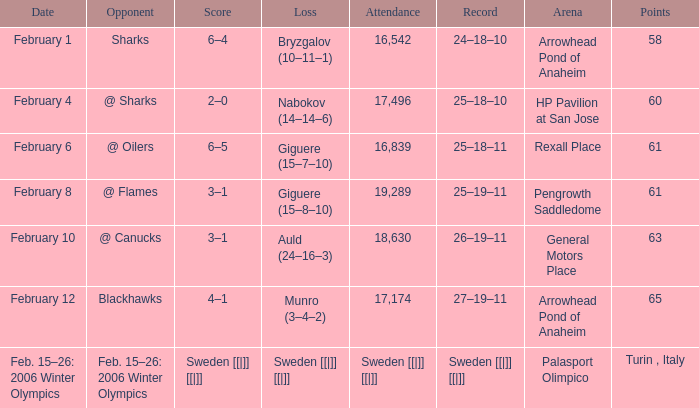What is the Arena when there were 65 points? Arrowhead Pond of Anaheim. 